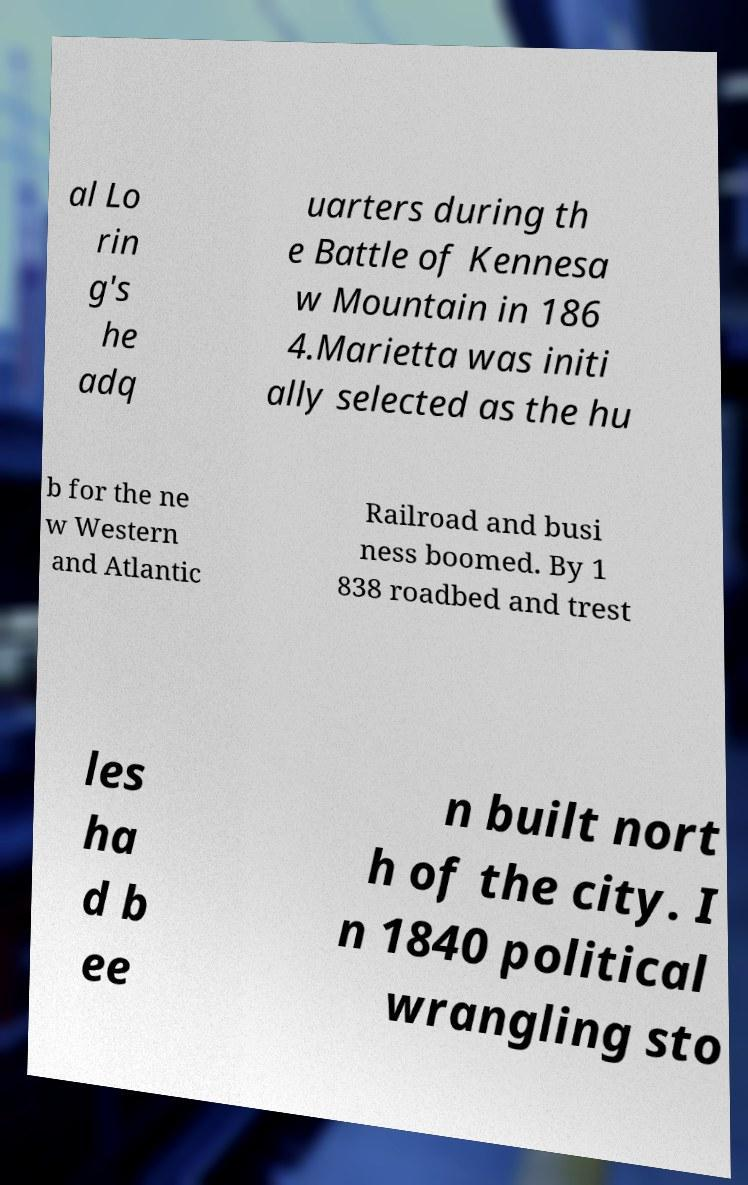Please read and relay the text visible in this image. What does it say? al Lo rin g's he adq uarters during th e Battle of Kennesa w Mountain in 186 4.Marietta was initi ally selected as the hu b for the ne w Western and Atlantic Railroad and busi ness boomed. By 1 838 roadbed and trest les ha d b ee n built nort h of the city. I n 1840 political wrangling sto 